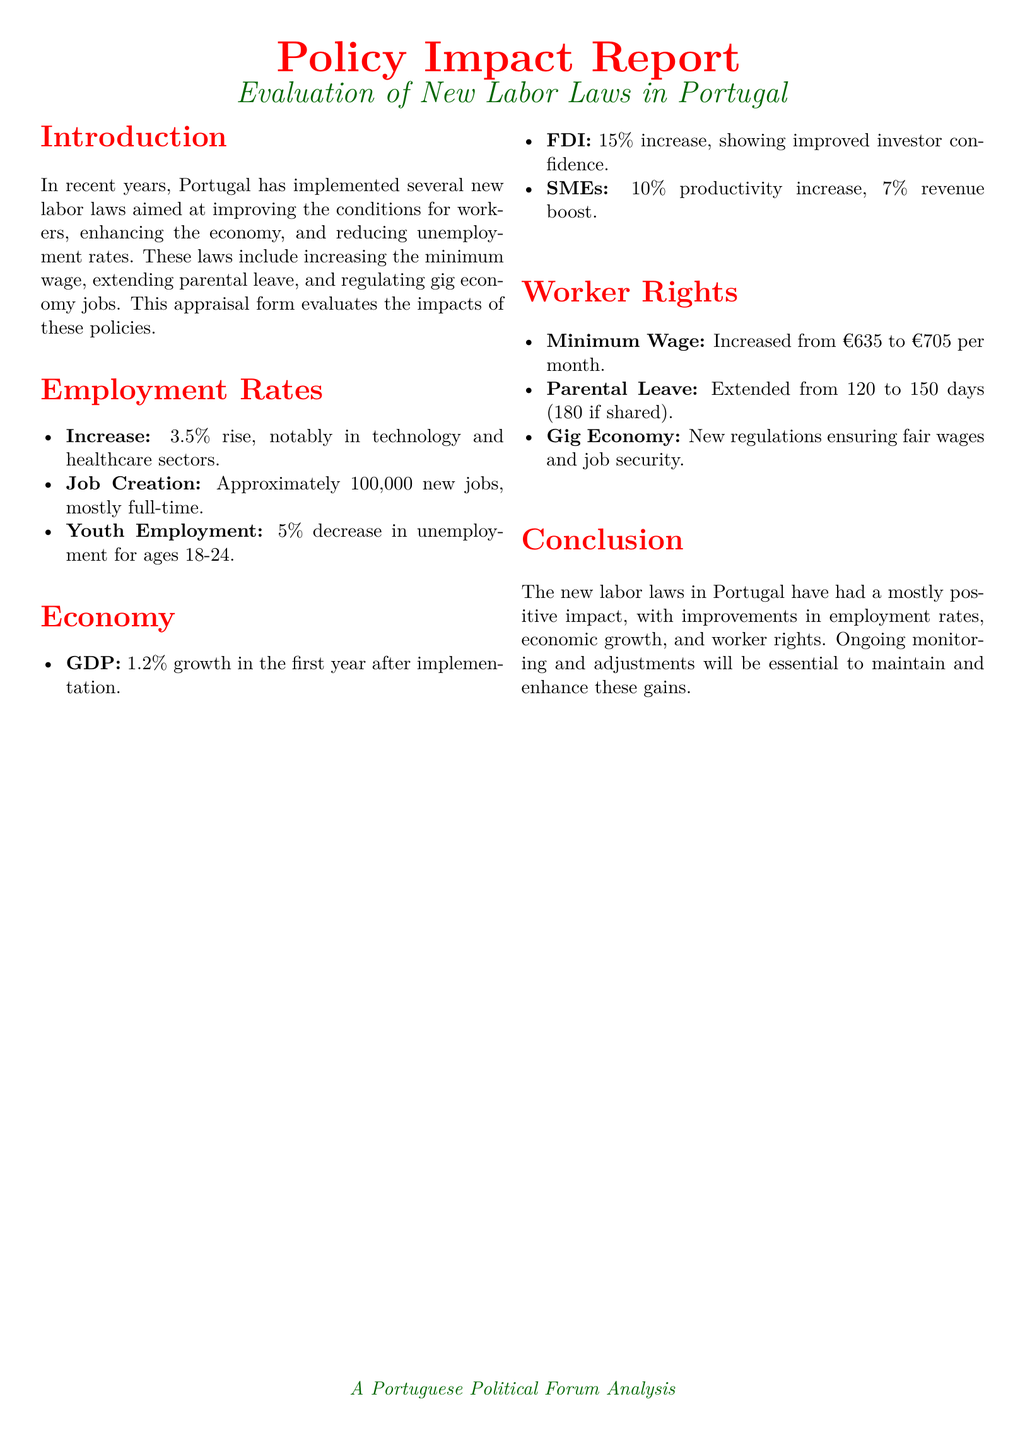what is the increase in employment rates? The document states a 3.5% rise in employment rates following the new labor laws.
Answer: 3.5% how many new jobs were created? Approximately 100,000 new jobs were created, mostly full-time.
Answer: 100,000 what was the GDP growth in the first year? The document indicates a 1.2% growth in GDP in the first year after implementation.
Answer: 1.2% what is the new minimum wage? The minimum wage was increased from €635 to €705 per month.
Answer: €705 by what percentage did youth unemployment decrease? There was a 5% decrease in unemployment for ages 18-24 due to the new laws.
Answer: 5% what percentage increase was noted in Foreign Direct Investment? A 15% increase in Foreign Direct Investment was observed.
Answer: 15% how long is the new parental leave? The parental leave was extended from 120 to 150 days, or 180 if shared.
Answer: 150 days what sector saw notable job increases? The document mentions notable increases in the technology and healthcare sectors.
Answer: technology and healthcare what is the productivity increase for SMEs? According to the report, SMEs experienced a 10% productivity increase.
Answer: 10% 